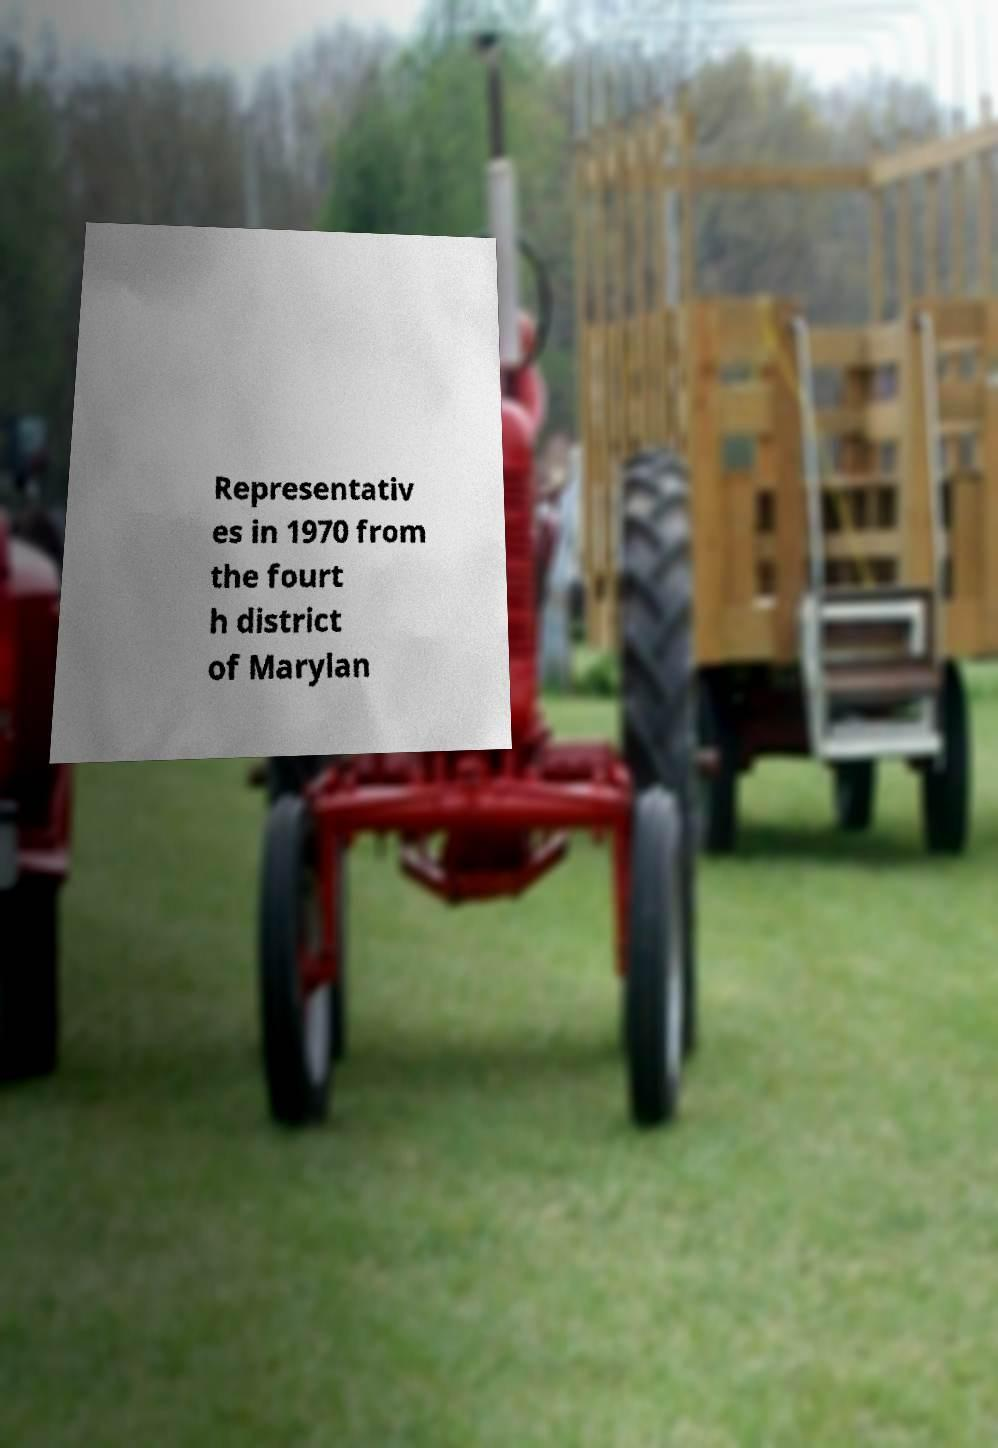I need the written content from this picture converted into text. Can you do that? Representativ es in 1970 from the fourt h district of Marylan 